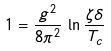Convert formula to latex. <formula><loc_0><loc_0><loc_500><loc_500>1 = \frac { g ^ { 2 } } { 8 \pi ^ { 2 } } \, \ln \frac { \zeta \delta } { T _ { c } }</formula> 